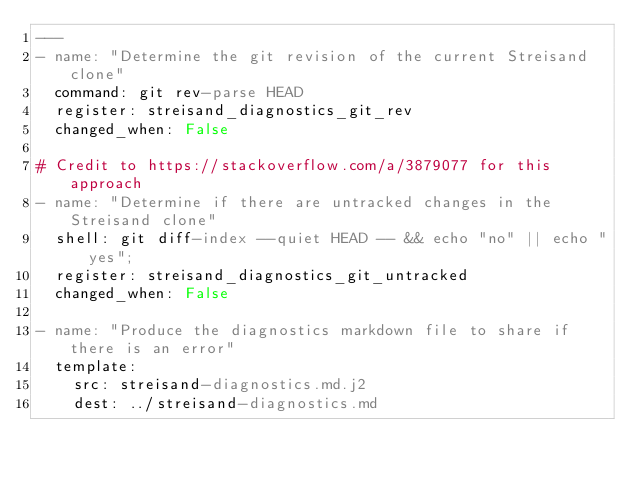<code> <loc_0><loc_0><loc_500><loc_500><_YAML_>---
- name: "Determine the git revision of the current Streisand clone"
  command: git rev-parse HEAD
  register: streisand_diagnostics_git_rev
  changed_when: False

# Credit to https://stackoverflow.com/a/3879077 for this approach
- name: "Determine if there are untracked changes in the Streisand clone"
  shell: git diff-index --quiet HEAD -- && echo "no" || echo "yes";
  register: streisand_diagnostics_git_untracked
  changed_when: False

- name: "Produce the diagnostics markdown file to share if there is an error"
  template:
    src: streisand-diagnostics.md.j2
    dest: ../streisand-diagnostics.md
</code> 